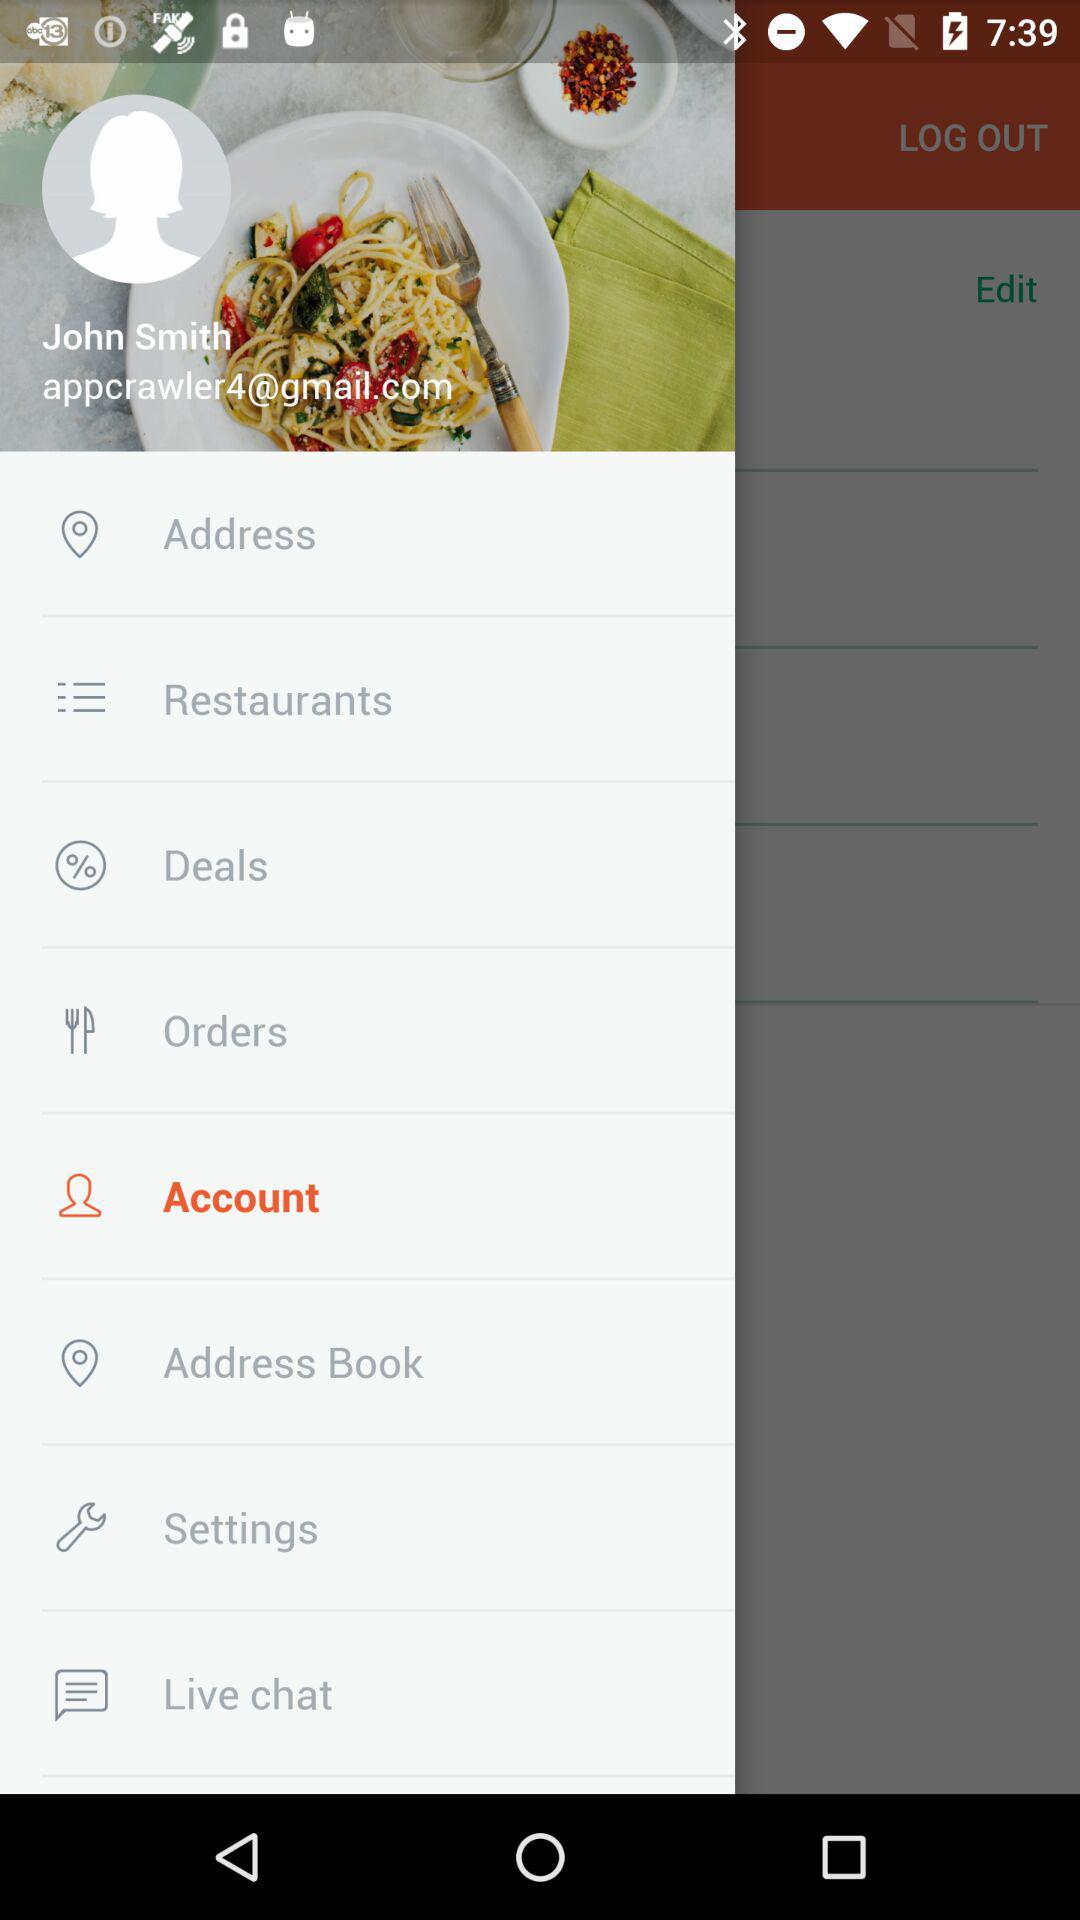What is the user name? The user name is John Smith. 